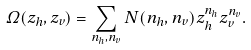Convert formula to latex. <formula><loc_0><loc_0><loc_500><loc_500>\Omega ( z _ { h } , z _ { v } ) = \sum _ { n _ { h } , n _ { v } } N ( n _ { h } , n _ { v } ) z _ { h } ^ { n _ { h } } z _ { v } ^ { n _ { v } } .</formula> 